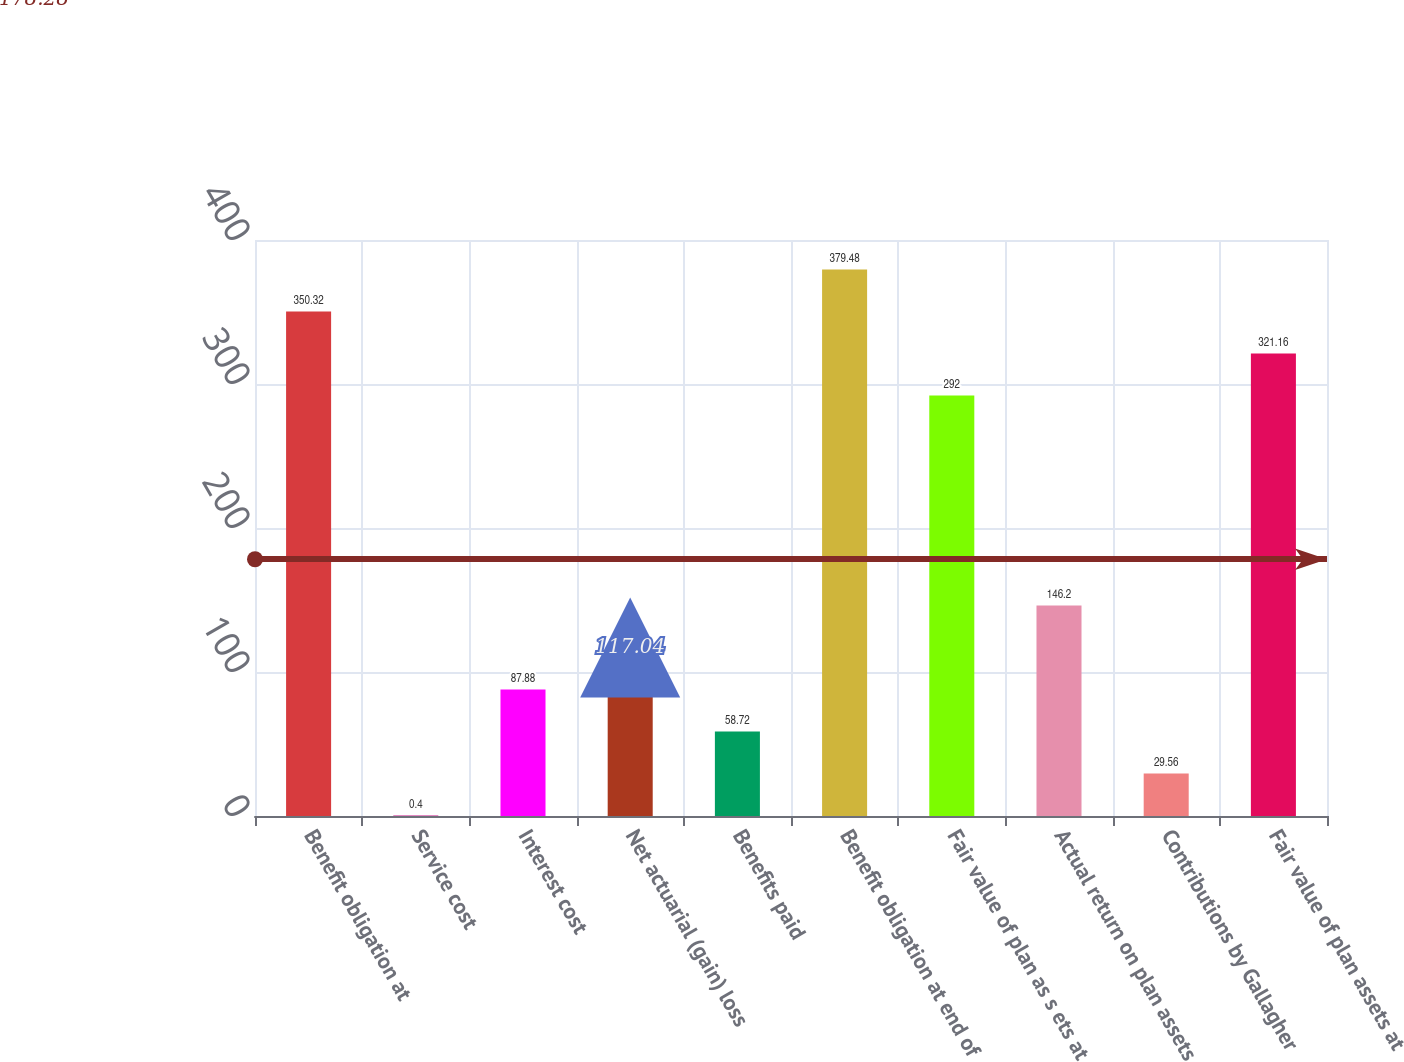Convert chart. <chart><loc_0><loc_0><loc_500><loc_500><bar_chart><fcel>Benefit obligation at<fcel>Service cost<fcel>Interest cost<fcel>Net actuarial (gain) loss<fcel>Benefits paid<fcel>Benefit obligation at end of<fcel>Fair value of plan as s ets at<fcel>Actual return on plan assets<fcel>Contributions by Gallagher<fcel>Fair value of plan assets at<nl><fcel>350.32<fcel>0.4<fcel>87.88<fcel>117.04<fcel>58.72<fcel>379.48<fcel>292<fcel>146.2<fcel>29.56<fcel>321.16<nl></chart> 